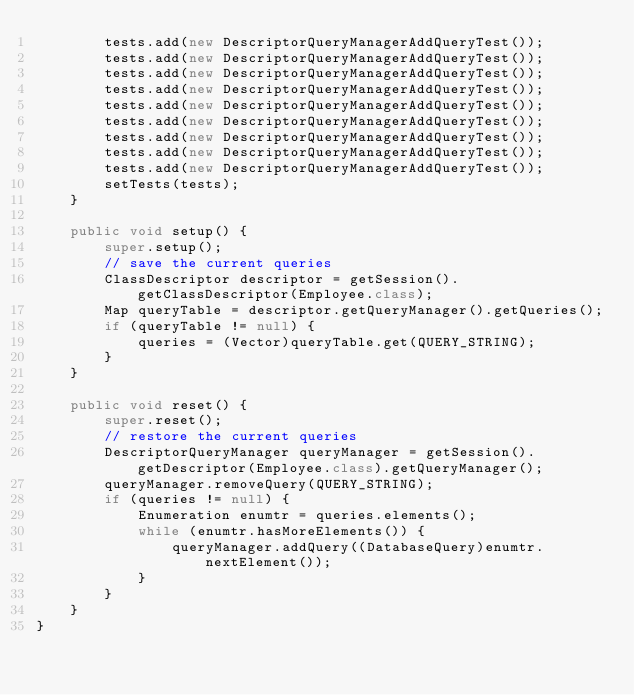Convert code to text. <code><loc_0><loc_0><loc_500><loc_500><_Java_>        tests.add(new DescriptorQueryManagerAddQueryTest());
        tests.add(new DescriptorQueryManagerAddQueryTest());
        tests.add(new DescriptorQueryManagerAddQueryTest());
        tests.add(new DescriptorQueryManagerAddQueryTest());
        tests.add(new DescriptorQueryManagerAddQueryTest());
        tests.add(new DescriptorQueryManagerAddQueryTest());
        tests.add(new DescriptorQueryManagerAddQueryTest());
        tests.add(new DescriptorQueryManagerAddQueryTest());
        tests.add(new DescriptorQueryManagerAddQueryTest());
        setTests(tests);
    }

    public void setup() {
        super.setup();
        // save the current queries
        ClassDescriptor descriptor = getSession().getClassDescriptor(Employee.class);
        Map queryTable = descriptor.getQueryManager().getQueries();
        if (queryTable != null) {
            queries = (Vector)queryTable.get(QUERY_STRING);
        }
    }

    public void reset() {
        super.reset();
        // restore the current queries
        DescriptorQueryManager queryManager = getSession().getDescriptor(Employee.class).getQueryManager();
        queryManager.removeQuery(QUERY_STRING);
        if (queries != null) {
            Enumeration enumtr = queries.elements();
            while (enumtr.hasMoreElements()) {
                queryManager.addQuery((DatabaseQuery)enumtr.nextElement());
            }
        }
    }
}
</code> 